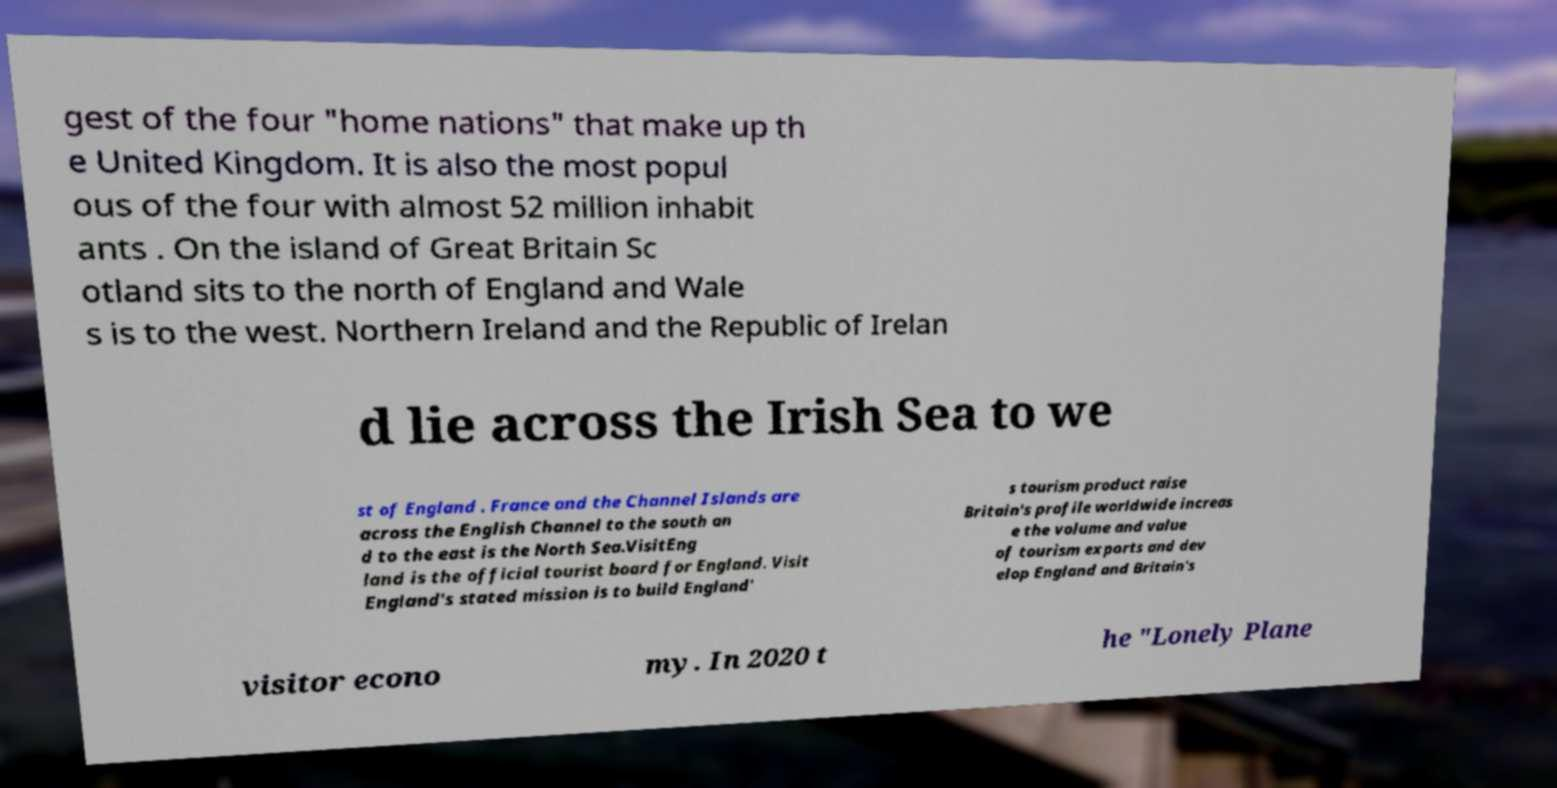Can you read and provide the text displayed in the image?This photo seems to have some interesting text. Can you extract and type it out for me? gest of the four "home nations" that make up th e United Kingdom. It is also the most popul ous of the four with almost 52 million inhabit ants . On the island of Great Britain Sc otland sits to the north of England and Wale s is to the west. Northern Ireland and the Republic of Irelan d lie across the Irish Sea to we st of England . France and the Channel Islands are across the English Channel to the south an d to the east is the North Sea.VisitEng land is the official tourist board for England. Visit England's stated mission is to build England' s tourism product raise Britain's profile worldwide increas e the volume and value of tourism exports and dev elop England and Britain's visitor econo my. In 2020 t he "Lonely Plane 